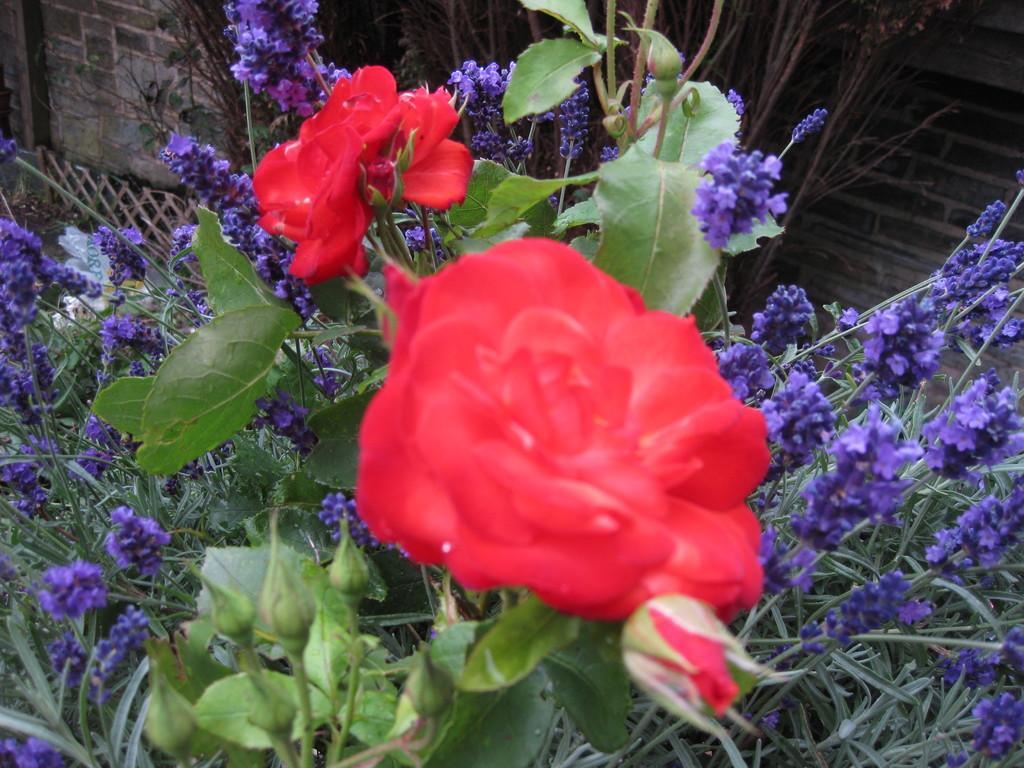Describe this image in one or two sentences. In the image we can see some flowers and plants. Behind the plants there is wall. 